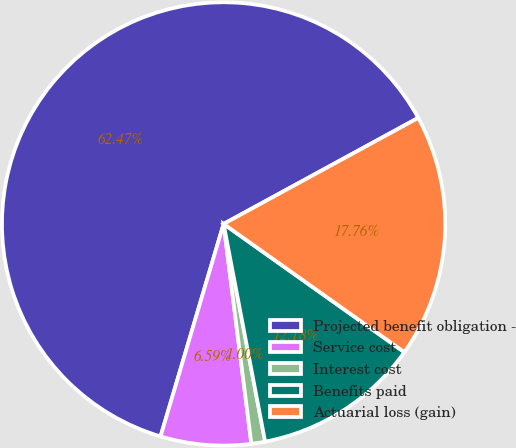Convert chart to OTSL. <chart><loc_0><loc_0><loc_500><loc_500><pie_chart><fcel>Projected benefit obligation -<fcel>Service cost<fcel>Interest cost<fcel>Benefits paid<fcel>Actuarial loss (gain)<nl><fcel>62.47%<fcel>6.59%<fcel>1.0%<fcel>12.18%<fcel>17.76%<nl></chart> 